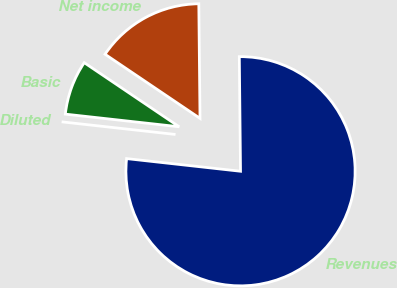<chart> <loc_0><loc_0><loc_500><loc_500><pie_chart><fcel>Revenues<fcel>Net income<fcel>Basic<fcel>Diluted<nl><fcel>76.92%<fcel>15.38%<fcel>7.69%<fcel>0.0%<nl></chart> 